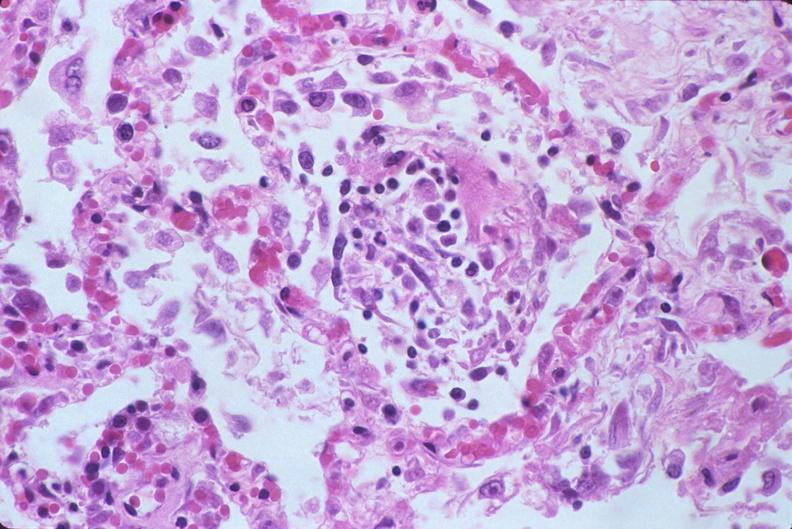does this image show lung, diffuse alveolar damage?
Answer the question using a single word or phrase. Yes 